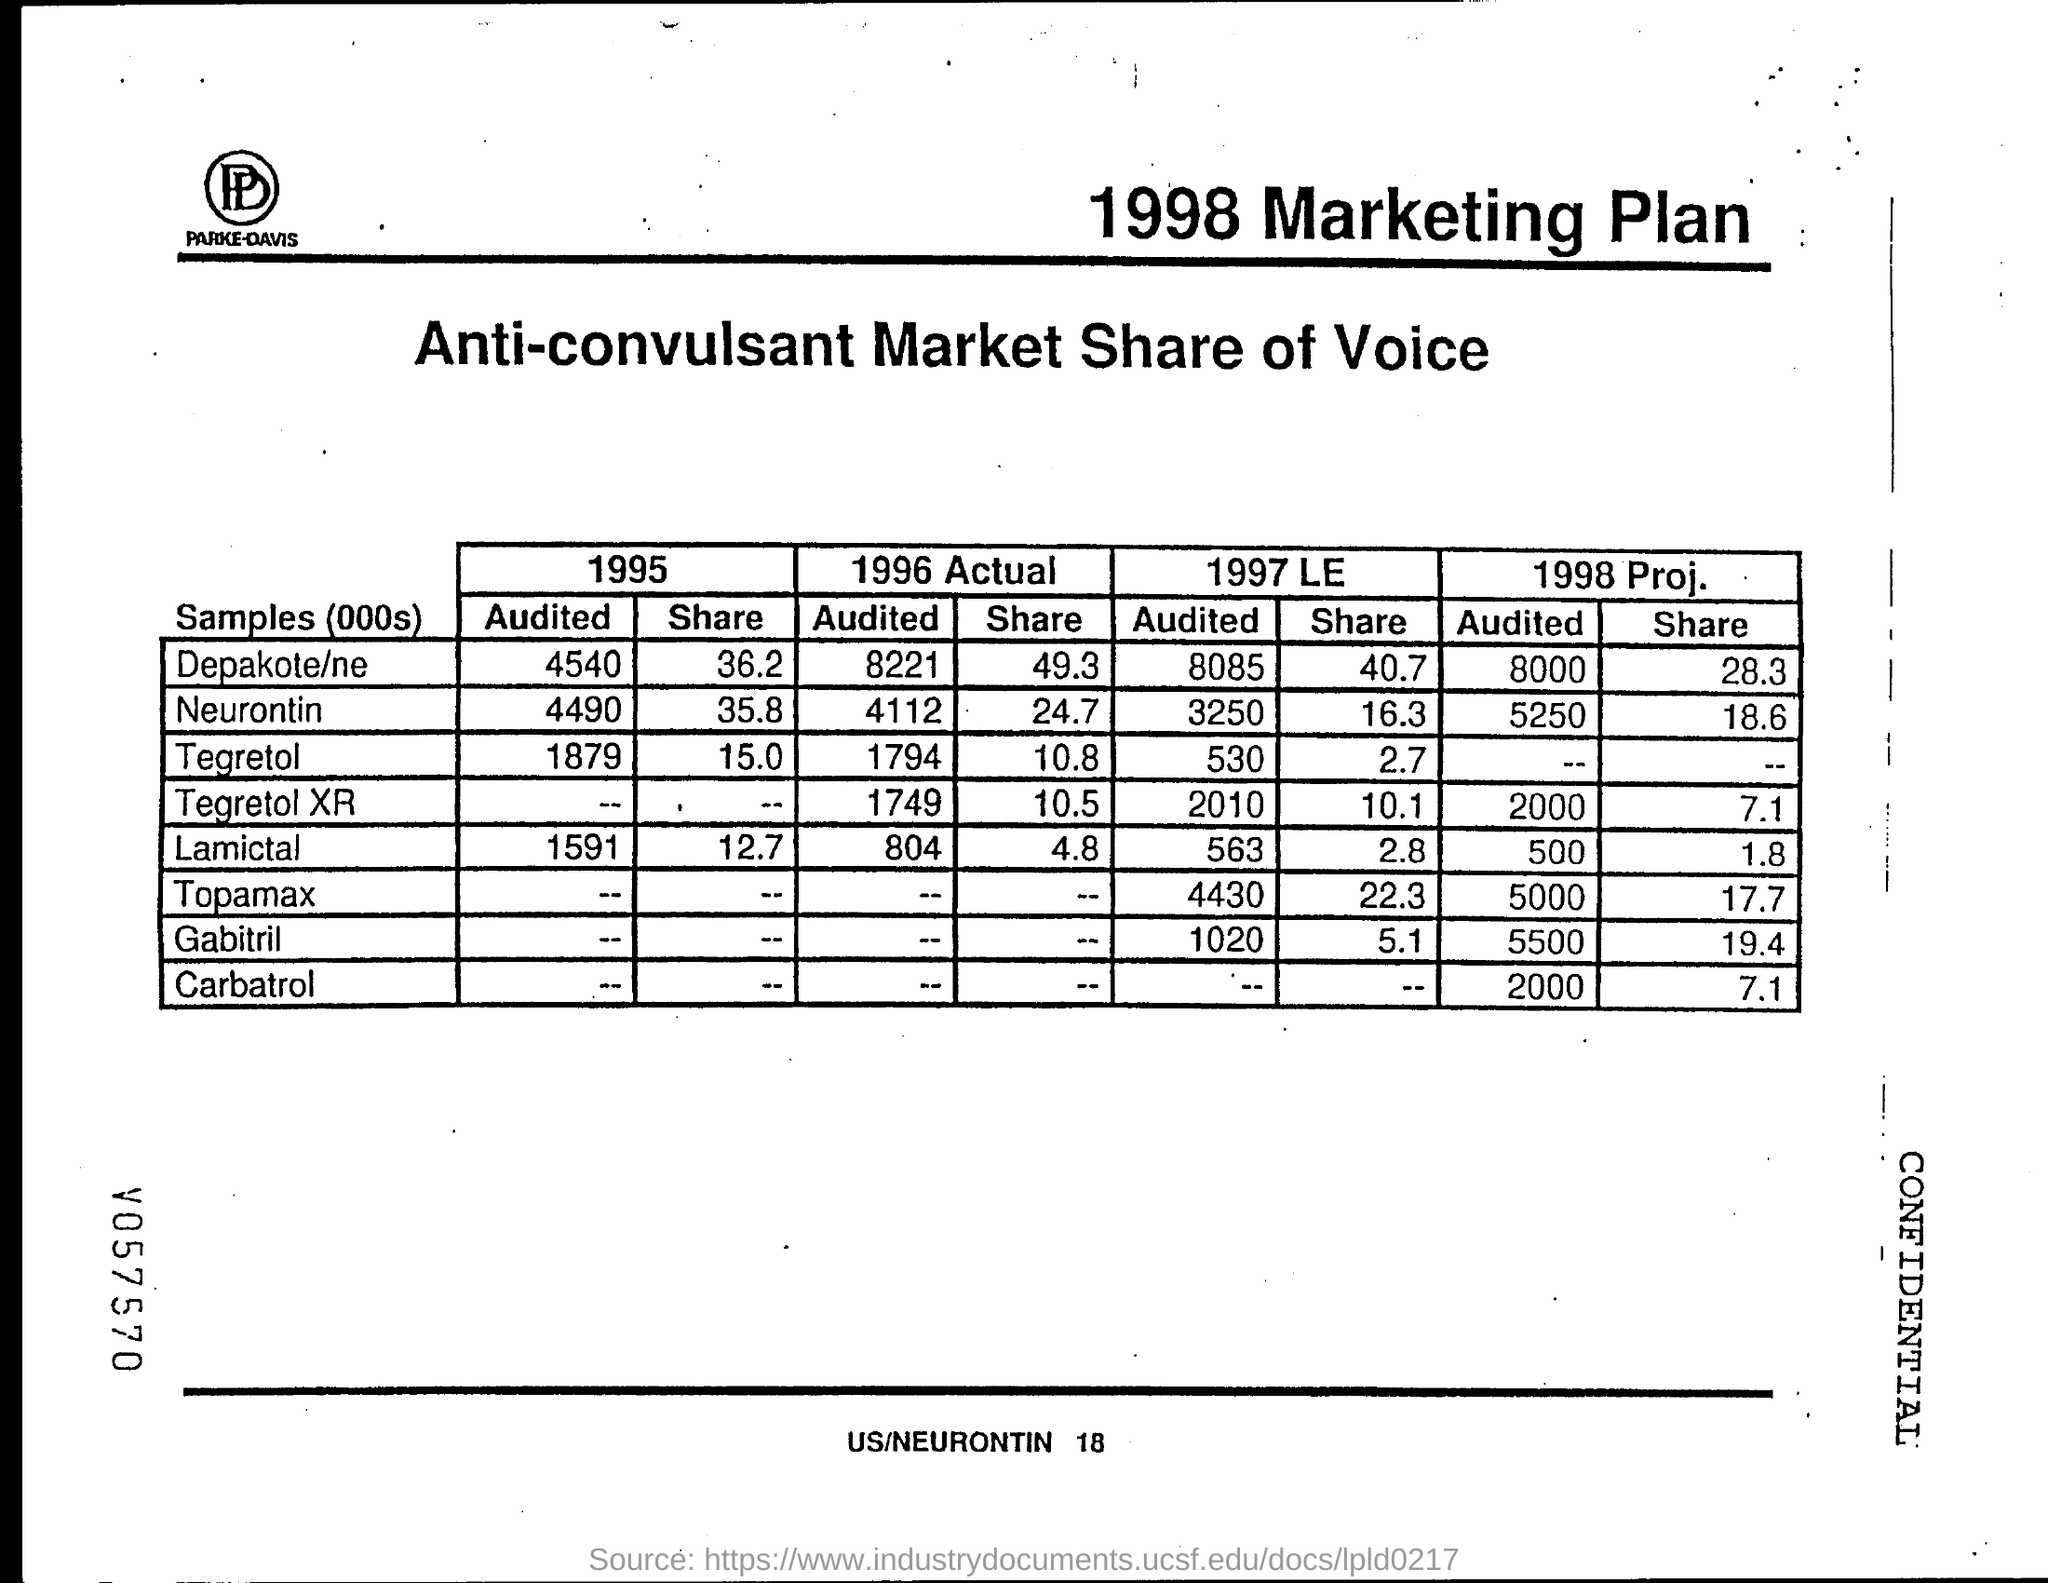What is the Lamictal "audited" value for 1995?
Make the answer very short. 1591. What is the Depakote/ne "audited" value for 1995?
Ensure brevity in your answer.  4540. What is the Neurontin "audited" value for 1995?
Make the answer very short. 4490. What is the Tegretol "audited" value for 1995?
Provide a succinct answer. 1879. What is the Lamictal "share" value for 1995?
Provide a short and direct response. 12.7. What is the Depakote/ne "share" value for 1995?
Provide a succinct answer. 36.2. What is the Tegretol "shared" value for 1995?
Offer a very short reply. 15.0. What is the Neurontin "share" value for 1995?
Give a very brief answer. 35.8. What is the Neurontin "audited" value for 1996 Actual?
Make the answer very short. 4112. What is the Tegretol "audited" value for 1996 Actual?
Ensure brevity in your answer.  1794. 